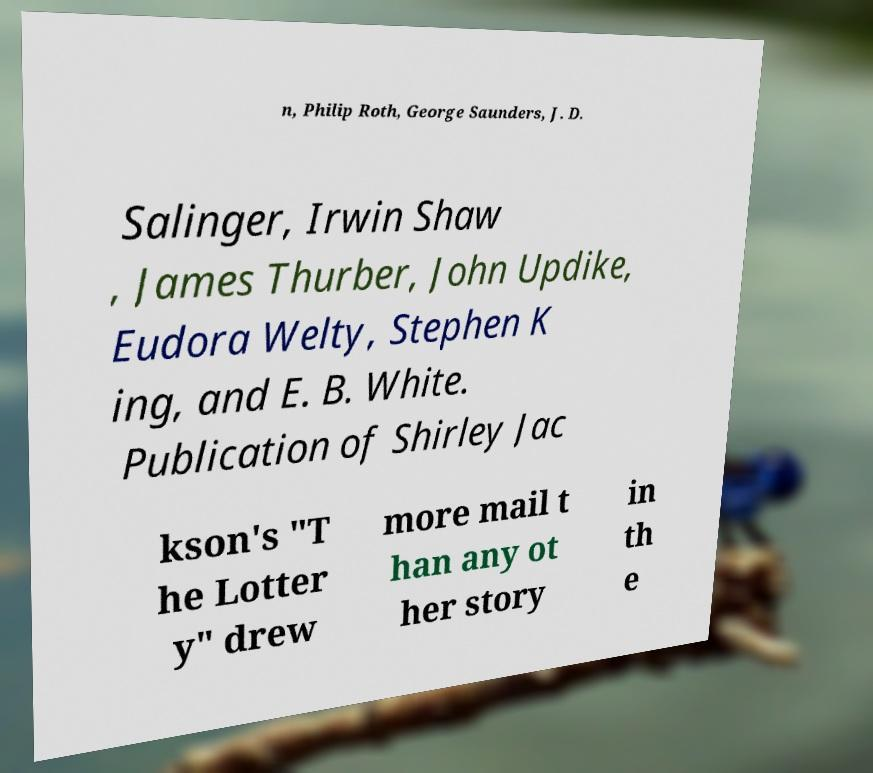What messages or text are displayed in this image? I need them in a readable, typed format. n, Philip Roth, George Saunders, J. D. Salinger, Irwin Shaw , James Thurber, John Updike, Eudora Welty, Stephen K ing, and E. B. White. Publication of Shirley Jac kson's "T he Lotter y" drew more mail t han any ot her story in th e 